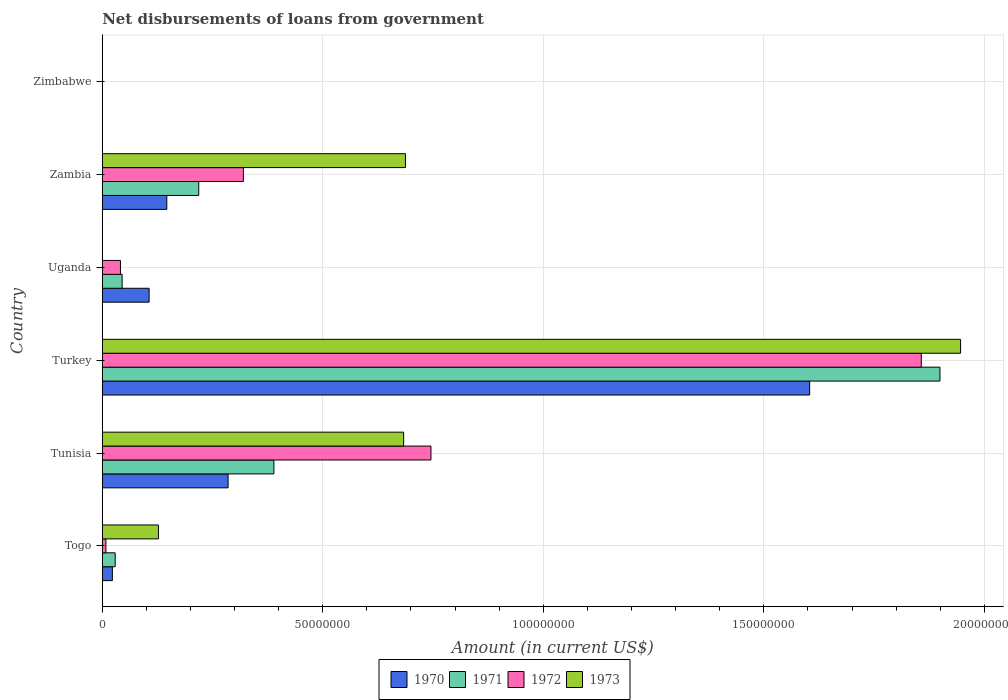How many different coloured bars are there?
Your response must be concise. 4. Are the number of bars on each tick of the Y-axis equal?
Offer a very short reply. No. How many bars are there on the 6th tick from the top?
Offer a terse response. 4. How many bars are there on the 6th tick from the bottom?
Offer a terse response. 0. What is the label of the 6th group of bars from the top?
Provide a succinct answer. Togo. What is the amount of loan disbursed from government in 1973 in Zambia?
Your answer should be very brief. 6.88e+07. Across all countries, what is the maximum amount of loan disbursed from government in 1971?
Your response must be concise. 1.90e+08. In which country was the amount of loan disbursed from government in 1972 maximum?
Provide a succinct answer. Turkey. What is the total amount of loan disbursed from government in 1970 in the graph?
Offer a very short reply. 2.16e+08. What is the difference between the amount of loan disbursed from government in 1973 in Togo and that in Tunisia?
Your response must be concise. -5.56e+07. What is the difference between the amount of loan disbursed from government in 1971 in Tunisia and the amount of loan disbursed from government in 1972 in Turkey?
Provide a succinct answer. -1.47e+08. What is the average amount of loan disbursed from government in 1973 per country?
Make the answer very short. 5.74e+07. What is the difference between the amount of loan disbursed from government in 1973 and amount of loan disbursed from government in 1972 in Turkey?
Make the answer very short. 8.91e+06. What is the ratio of the amount of loan disbursed from government in 1971 in Turkey to that in Zambia?
Offer a terse response. 8.68. Is the amount of loan disbursed from government in 1970 in Turkey less than that in Uganda?
Provide a short and direct response. No. What is the difference between the highest and the second highest amount of loan disbursed from government in 1972?
Ensure brevity in your answer.  1.11e+08. What is the difference between the highest and the lowest amount of loan disbursed from government in 1972?
Give a very brief answer. 1.86e+08. Is the sum of the amount of loan disbursed from government in 1970 in Uganda and Zambia greater than the maximum amount of loan disbursed from government in 1972 across all countries?
Provide a succinct answer. No. Is it the case that in every country, the sum of the amount of loan disbursed from government in 1970 and amount of loan disbursed from government in 1971 is greater than the sum of amount of loan disbursed from government in 1973 and amount of loan disbursed from government in 1972?
Your answer should be compact. No. How many bars are there?
Offer a very short reply. 19. Are all the bars in the graph horizontal?
Your answer should be very brief. Yes. How many countries are there in the graph?
Offer a very short reply. 6. Does the graph contain any zero values?
Provide a succinct answer. Yes. Does the graph contain grids?
Your answer should be very brief. Yes. Where does the legend appear in the graph?
Provide a succinct answer. Bottom center. How are the legend labels stacked?
Provide a short and direct response. Horizontal. What is the title of the graph?
Offer a very short reply. Net disbursements of loans from government. What is the label or title of the X-axis?
Your response must be concise. Amount (in current US$). What is the label or title of the Y-axis?
Give a very brief answer. Country. What is the Amount (in current US$) in 1970 in Togo?
Offer a terse response. 2.30e+06. What is the Amount (in current US$) of 1971 in Togo?
Your answer should be compact. 2.94e+06. What is the Amount (in current US$) in 1972 in Togo?
Give a very brief answer. 8.31e+05. What is the Amount (in current US$) of 1973 in Togo?
Provide a succinct answer. 1.27e+07. What is the Amount (in current US$) in 1970 in Tunisia?
Your response must be concise. 2.85e+07. What is the Amount (in current US$) of 1971 in Tunisia?
Ensure brevity in your answer.  3.89e+07. What is the Amount (in current US$) of 1972 in Tunisia?
Offer a very short reply. 7.45e+07. What is the Amount (in current US$) of 1973 in Tunisia?
Your response must be concise. 6.83e+07. What is the Amount (in current US$) in 1970 in Turkey?
Offer a terse response. 1.60e+08. What is the Amount (in current US$) in 1971 in Turkey?
Your response must be concise. 1.90e+08. What is the Amount (in current US$) of 1972 in Turkey?
Provide a succinct answer. 1.86e+08. What is the Amount (in current US$) in 1973 in Turkey?
Offer a very short reply. 1.95e+08. What is the Amount (in current US$) of 1970 in Uganda?
Ensure brevity in your answer.  1.06e+07. What is the Amount (in current US$) of 1971 in Uganda?
Your answer should be compact. 4.51e+06. What is the Amount (in current US$) in 1972 in Uganda?
Provide a short and direct response. 4.13e+06. What is the Amount (in current US$) of 1970 in Zambia?
Offer a terse response. 1.46e+07. What is the Amount (in current US$) of 1971 in Zambia?
Your answer should be compact. 2.19e+07. What is the Amount (in current US$) in 1972 in Zambia?
Give a very brief answer. 3.20e+07. What is the Amount (in current US$) in 1973 in Zambia?
Give a very brief answer. 6.88e+07. What is the Amount (in current US$) of 1972 in Zimbabwe?
Provide a succinct answer. 0. Across all countries, what is the maximum Amount (in current US$) of 1970?
Provide a short and direct response. 1.60e+08. Across all countries, what is the maximum Amount (in current US$) of 1971?
Offer a very short reply. 1.90e+08. Across all countries, what is the maximum Amount (in current US$) in 1972?
Offer a terse response. 1.86e+08. Across all countries, what is the maximum Amount (in current US$) in 1973?
Keep it short and to the point. 1.95e+08. Across all countries, what is the minimum Amount (in current US$) in 1970?
Your answer should be compact. 0. Across all countries, what is the minimum Amount (in current US$) of 1973?
Your answer should be very brief. 0. What is the total Amount (in current US$) in 1970 in the graph?
Provide a succinct answer. 2.16e+08. What is the total Amount (in current US$) in 1971 in the graph?
Your answer should be compact. 2.58e+08. What is the total Amount (in current US$) in 1972 in the graph?
Keep it short and to the point. 2.97e+08. What is the total Amount (in current US$) of 1973 in the graph?
Provide a short and direct response. 3.44e+08. What is the difference between the Amount (in current US$) in 1970 in Togo and that in Tunisia?
Offer a very short reply. -2.62e+07. What is the difference between the Amount (in current US$) in 1971 in Togo and that in Tunisia?
Make the answer very short. -3.60e+07. What is the difference between the Amount (in current US$) in 1972 in Togo and that in Tunisia?
Offer a terse response. -7.37e+07. What is the difference between the Amount (in current US$) of 1973 in Togo and that in Tunisia?
Provide a succinct answer. -5.56e+07. What is the difference between the Amount (in current US$) of 1970 in Togo and that in Turkey?
Provide a succinct answer. -1.58e+08. What is the difference between the Amount (in current US$) in 1971 in Togo and that in Turkey?
Keep it short and to the point. -1.87e+08. What is the difference between the Amount (in current US$) in 1972 in Togo and that in Turkey?
Offer a terse response. -1.85e+08. What is the difference between the Amount (in current US$) of 1973 in Togo and that in Turkey?
Your answer should be very brief. -1.82e+08. What is the difference between the Amount (in current US$) in 1970 in Togo and that in Uganda?
Your answer should be very brief. -8.33e+06. What is the difference between the Amount (in current US$) in 1971 in Togo and that in Uganda?
Keep it short and to the point. -1.57e+06. What is the difference between the Amount (in current US$) in 1972 in Togo and that in Uganda?
Provide a succinct answer. -3.30e+06. What is the difference between the Amount (in current US$) in 1970 in Togo and that in Zambia?
Offer a terse response. -1.23e+07. What is the difference between the Amount (in current US$) in 1971 in Togo and that in Zambia?
Keep it short and to the point. -1.89e+07. What is the difference between the Amount (in current US$) in 1972 in Togo and that in Zambia?
Offer a terse response. -3.12e+07. What is the difference between the Amount (in current US$) in 1973 in Togo and that in Zambia?
Your answer should be compact. -5.60e+07. What is the difference between the Amount (in current US$) in 1970 in Tunisia and that in Turkey?
Your response must be concise. -1.32e+08. What is the difference between the Amount (in current US$) of 1971 in Tunisia and that in Turkey?
Make the answer very short. -1.51e+08. What is the difference between the Amount (in current US$) of 1972 in Tunisia and that in Turkey?
Your response must be concise. -1.11e+08. What is the difference between the Amount (in current US$) in 1973 in Tunisia and that in Turkey?
Provide a succinct answer. -1.26e+08. What is the difference between the Amount (in current US$) of 1970 in Tunisia and that in Uganda?
Your answer should be very brief. 1.79e+07. What is the difference between the Amount (in current US$) in 1971 in Tunisia and that in Uganda?
Provide a short and direct response. 3.44e+07. What is the difference between the Amount (in current US$) in 1972 in Tunisia and that in Uganda?
Ensure brevity in your answer.  7.04e+07. What is the difference between the Amount (in current US$) in 1970 in Tunisia and that in Zambia?
Offer a very short reply. 1.39e+07. What is the difference between the Amount (in current US$) in 1971 in Tunisia and that in Zambia?
Provide a short and direct response. 1.70e+07. What is the difference between the Amount (in current US$) in 1972 in Tunisia and that in Zambia?
Offer a very short reply. 4.25e+07. What is the difference between the Amount (in current US$) in 1973 in Tunisia and that in Zambia?
Ensure brevity in your answer.  -4.12e+05. What is the difference between the Amount (in current US$) in 1970 in Turkey and that in Uganda?
Your answer should be very brief. 1.50e+08. What is the difference between the Amount (in current US$) of 1971 in Turkey and that in Uganda?
Your answer should be compact. 1.85e+08. What is the difference between the Amount (in current US$) of 1972 in Turkey and that in Uganda?
Keep it short and to the point. 1.82e+08. What is the difference between the Amount (in current US$) in 1970 in Turkey and that in Zambia?
Provide a short and direct response. 1.46e+08. What is the difference between the Amount (in current US$) of 1971 in Turkey and that in Zambia?
Your response must be concise. 1.68e+08. What is the difference between the Amount (in current US$) in 1972 in Turkey and that in Zambia?
Your answer should be compact. 1.54e+08. What is the difference between the Amount (in current US$) in 1973 in Turkey and that in Zambia?
Offer a terse response. 1.26e+08. What is the difference between the Amount (in current US$) of 1970 in Uganda and that in Zambia?
Provide a succinct answer. -4.01e+06. What is the difference between the Amount (in current US$) in 1971 in Uganda and that in Zambia?
Provide a succinct answer. -1.74e+07. What is the difference between the Amount (in current US$) in 1972 in Uganda and that in Zambia?
Your answer should be very brief. -2.79e+07. What is the difference between the Amount (in current US$) in 1970 in Togo and the Amount (in current US$) in 1971 in Tunisia?
Provide a short and direct response. -3.66e+07. What is the difference between the Amount (in current US$) in 1970 in Togo and the Amount (in current US$) in 1972 in Tunisia?
Ensure brevity in your answer.  -7.22e+07. What is the difference between the Amount (in current US$) in 1970 in Togo and the Amount (in current US$) in 1973 in Tunisia?
Ensure brevity in your answer.  -6.60e+07. What is the difference between the Amount (in current US$) in 1971 in Togo and the Amount (in current US$) in 1972 in Tunisia?
Offer a very short reply. -7.16e+07. What is the difference between the Amount (in current US$) of 1971 in Togo and the Amount (in current US$) of 1973 in Tunisia?
Offer a very short reply. -6.54e+07. What is the difference between the Amount (in current US$) of 1972 in Togo and the Amount (in current US$) of 1973 in Tunisia?
Offer a terse response. -6.75e+07. What is the difference between the Amount (in current US$) in 1970 in Togo and the Amount (in current US$) in 1971 in Turkey?
Offer a very short reply. -1.88e+08. What is the difference between the Amount (in current US$) in 1970 in Togo and the Amount (in current US$) in 1972 in Turkey?
Offer a very short reply. -1.83e+08. What is the difference between the Amount (in current US$) in 1970 in Togo and the Amount (in current US$) in 1973 in Turkey?
Provide a succinct answer. -1.92e+08. What is the difference between the Amount (in current US$) in 1971 in Togo and the Amount (in current US$) in 1972 in Turkey?
Give a very brief answer. -1.83e+08. What is the difference between the Amount (in current US$) in 1971 in Togo and the Amount (in current US$) in 1973 in Turkey?
Make the answer very short. -1.92e+08. What is the difference between the Amount (in current US$) in 1972 in Togo and the Amount (in current US$) in 1973 in Turkey?
Provide a succinct answer. -1.94e+08. What is the difference between the Amount (in current US$) in 1970 in Togo and the Amount (in current US$) in 1971 in Uganda?
Offer a terse response. -2.21e+06. What is the difference between the Amount (in current US$) of 1970 in Togo and the Amount (in current US$) of 1972 in Uganda?
Offer a terse response. -1.83e+06. What is the difference between the Amount (in current US$) in 1971 in Togo and the Amount (in current US$) in 1972 in Uganda?
Ensure brevity in your answer.  -1.20e+06. What is the difference between the Amount (in current US$) in 1970 in Togo and the Amount (in current US$) in 1971 in Zambia?
Offer a terse response. -1.96e+07. What is the difference between the Amount (in current US$) in 1970 in Togo and the Amount (in current US$) in 1972 in Zambia?
Provide a short and direct response. -2.97e+07. What is the difference between the Amount (in current US$) in 1970 in Togo and the Amount (in current US$) in 1973 in Zambia?
Give a very brief answer. -6.65e+07. What is the difference between the Amount (in current US$) in 1971 in Togo and the Amount (in current US$) in 1972 in Zambia?
Give a very brief answer. -2.91e+07. What is the difference between the Amount (in current US$) in 1971 in Togo and the Amount (in current US$) in 1973 in Zambia?
Your answer should be very brief. -6.58e+07. What is the difference between the Amount (in current US$) of 1972 in Togo and the Amount (in current US$) of 1973 in Zambia?
Offer a very short reply. -6.79e+07. What is the difference between the Amount (in current US$) of 1970 in Tunisia and the Amount (in current US$) of 1971 in Turkey?
Offer a terse response. -1.61e+08. What is the difference between the Amount (in current US$) in 1970 in Tunisia and the Amount (in current US$) in 1972 in Turkey?
Provide a succinct answer. -1.57e+08. What is the difference between the Amount (in current US$) in 1970 in Tunisia and the Amount (in current US$) in 1973 in Turkey?
Make the answer very short. -1.66e+08. What is the difference between the Amount (in current US$) of 1971 in Tunisia and the Amount (in current US$) of 1972 in Turkey?
Your response must be concise. -1.47e+08. What is the difference between the Amount (in current US$) in 1971 in Tunisia and the Amount (in current US$) in 1973 in Turkey?
Offer a very short reply. -1.56e+08. What is the difference between the Amount (in current US$) of 1972 in Tunisia and the Amount (in current US$) of 1973 in Turkey?
Offer a terse response. -1.20e+08. What is the difference between the Amount (in current US$) in 1970 in Tunisia and the Amount (in current US$) in 1971 in Uganda?
Make the answer very short. 2.40e+07. What is the difference between the Amount (in current US$) of 1970 in Tunisia and the Amount (in current US$) of 1972 in Uganda?
Make the answer very short. 2.44e+07. What is the difference between the Amount (in current US$) of 1971 in Tunisia and the Amount (in current US$) of 1972 in Uganda?
Provide a short and direct response. 3.48e+07. What is the difference between the Amount (in current US$) of 1970 in Tunisia and the Amount (in current US$) of 1971 in Zambia?
Offer a terse response. 6.66e+06. What is the difference between the Amount (in current US$) of 1970 in Tunisia and the Amount (in current US$) of 1972 in Zambia?
Provide a short and direct response. -3.46e+06. What is the difference between the Amount (in current US$) of 1970 in Tunisia and the Amount (in current US$) of 1973 in Zambia?
Ensure brevity in your answer.  -4.02e+07. What is the difference between the Amount (in current US$) of 1971 in Tunisia and the Amount (in current US$) of 1972 in Zambia?
Give a very brief answer. 6.92e+06. What is the difference between the Amount (in current US$) of 1971 in Tunisia and the Amount (in current US$) of 1973 in Zambia?
Your response must be concise. -2.98e+07. What is the difference between the Amount (in current US$) in 1972 in Tunisia and the Amount (in current US$) in 1973 in Zambia?
Your response must be concise. 5.78e+06. What is the difference between the Amount (in current US$) in 1970 in Turkey and the Amount (in current US$) in 1971 in Uganda?
Ensure brevity in your answer.  1.56e+08. What is the difference between the Amount (in current US$) of 1970 in Turkey and the Amount (in current US$) of 1972 in Uganda?
Offer a terse response. 1.56e+08. What is the difference between the Amount (in current US$) of 1971 in Turkey and the Amount (in current US$) of 1972 in Uganda?
Provide a succinct answer. 1.86e+08. What is the difference between the Amount (in current US$) in 1970 in Turkey and the Amount (in current US$) in 1971 in Zambia?
Make the answer very short. 1.39e+08. What is the difference between the Amount (in current US$) of 1970 in Turkey and the Amount (in current US$) of 1972 in Zambia?
Offer a very short reply. 1.28e+08. What is the difference between the Amount (in current US$) in 1970 in Turkey and the Amount (in current US$) in 1973 in Zambia?
Offer a terse response. 9.16e+07. What is the difference between the Amount (in current US$) in 1971 in Turkey and the Amount (in current US$) in 1972 in Zambia?
Offer a terse response. 1.58e+08. What is the difference between the Amount (in current US$) in 1971 in Turkey and the Amount (in current US$) in 1973 in Zambia?
Your answer should be compact. 1.21e+08. What is the difference between the Amount (in current US$) in 1972 in Turkey and the Amount (in current US$) in 1973 in Zambia?
Your answer should be compact. 1.17e+08. What is the difference between the Amount (in current US$) in 1970 in Uganda and the Amount (in current US$) in 1971 in Zambia?
Provide a succinct answer. -1.13e+07. What is the difference between the Amount (in current US$) in 1970 in Uganda and the Amount (in current US$) in 1972 in Zambia?
Your response must be concise. -2.14e+07. What is the difference between the Amount (in current US$) of 1970 in Uganda and the Amount (in current US$) of 1973 in Zambia?
Your answer should be very brief. -5.81e+07. What is the difference between the Amount (in current US$) of 1971 in Uganda and the Amount (in current US$) of 1972 in Zambia?
Your answer should be compact. -2.75e+07. What is the difference between the Amount (in current US$) of 1971 in Uganda and the Amount (in current US$) of 1973 in Zambia?
Provide a succinct answer. -6.42e+07. What is the difference between the Amount (in current US$) in 1972 in Uganda and the Amount (in current US$) in 1973 in Zambia?
Keep it short and to the point. -6.46e+07. What is the average Amount (in current US$) of 1970 per country?
Offer a terse response. 3.61e+07. What is the average Amount (in current US$) in 1971 per country?
Offer a terse response. 4.30e+07. What is the average Amount (in current US$) in 1972 per country?
Your response must be concise. 4.95e+07. What is the average Amount (in current US$) in 1973 per country?
Offer a terse response. 5.74e+07. What is the difference between the Amount (in current US$) of 1970 and Amount (in current US$) of 1971 in Togo?
Provide a short and direct response. -6.37e+05. What is the difference between the Amount (in current US$) of 1970 and Amount (in current US$) of 1972 in Togo?
Make the answer very short. 1.47e+06. What is the difference between the Amount (in current US$) of 1970 and Amount (in current US$) of 1973 in Togo?
Keep it short and to the point. -1.04e+07. What is the difference between the Amount (in current US$) in 1971 and Amount (in current US$) in 1972 in Togo?
Your answer should be very brief. 2.10e+06. What is the difference between the Amount (in current US$) in 1971 and Amount (in current US$) in 1973 in Togo?
Keep it short and to the point. -9.80e+06. What is the difference between the Amount (in current US$) of 1972 and Amount (in current US$) of 1973 in Togo?
Keep it short and to the point. -1.19e+07. What is the difference between the Amount (in current US$) in 1970 and Amount (in current US$) in 1971 in Tunisia?
Provide a short and direct response. -1.04e+07. What is the difference between the Amount (in current US$) of 1970 and Amount (in current US$) of 1972 in Tunisia?
Ensure brevity in your answer.  -4.60e+07. What is the difference between the Amount (in current US$) of 1970 and Amount (in current US$) of 1973 in Tunisia?
Provide a short and direct response. -3.98e+07. What is the difference between the Amount (in current US$) in 1971 and Amount (in current US$) in 1972 in Tunisia?
Provide a short and direct response. -3.56e+07. What is the difference between the Amount (in current US$) of 1971 and Amount (in current US$) of 1973 in Tunisia?
Give a very brief answer. -2.94e+07. What is the difference between the Amount (in current US$) of 1972 and Amount (in current US$) of 1973 in Tunisia?
Provide a short and direct response. 6.20e+06. What is the difference between the Amount (in current US$) of 1970 and Amount (in current US$) of 1971 in Turkey?
Give a very brief answer. -2.95e+07. What is the difference between the Amount (in current US$) in 1970 and Amount (in current US$) in 1972 in Turkey?
Provide a succinct answer. -2.53e+07. What is the difference between the Amount (in current US$) of 1970 and Amount (in current US$) of 1973 in Turkey?
Your answer should be compact. -3.42e+07. What is the difference between the Amount (in current US$) in 1971 and Amount (in current US$) in 1972 in Turkey?
Your response must be concise. 4.24e+06. What is the difference between the Amount (in current US$) in 1971 and Amount (in current US$) in 1973 in Turkey?
Make the answer very short. -4.67e+06. What is the difference between the Amount (in current US$) in 1972 and Amount (in current US$) in 1973 in Turkey?
Provide a succinct answer. -8.91e+06. What is the difference between the Amount (in current US$) of 1970 and Amount (in current US$) of 1971 in Uganda?
Keep it short and to the point. 6.12e+06. What is the difference between the Amount (in current US$) of 1970 and Amount (in current US$) of 1972 in Uganda?
Your answer should be compact. 6.50e+06. What is the difference between the Amount (in current US$) of 1971 and Amount (in current US$) of 1972 in Uganda?
Your answer should be very brief. 3.77e+05. What is the difference between the Amount (in current US$) in 1970 and Amount (in current US$) in 1971 in Zambia?
Your response must be concise. -7.25e+06. What is the difference between the Amount (in current US$) in 1970 and Amount (in current US$) in 1972 in Zambia?
Your answer should be very brief. -1.74e+07. What is the difference between the Amount (in current US$) of 1970 and Amount (in current US$) of 1973 in Zambia?
Your response must be concise. -5.41e+07. What is the difference between the Amount (in current US$) of 1971 and Amount (in current US$) of 1972 in Zambia?
Give a very brief answer. -1.01e+07. What is the difference between the Amount (in current US$) of 1971 and Amount (in current US$) of 1973 in Zambia?
Provide a succinct answer. -4.69e+07. What is the difference between the Amount (in current US$) in 1972 and Amount (in current US$) in 1973 in Zambia?
Provide a succinct answer. -3.68e+07. What is the ratio of the Amount (in current US$) of 1970 in Togo to that in Tunisia?
Offer a very short reply. 0.08. What is the ratio of the Amount (in current US$) in 1971 in Togo to that in Tunisia?
Make the answer very short. 0.08. What is the ratio of the Amount (in current US$) in 1972 in Togo to that in Tunisia?
Your answer should be compact. 0.01. What is the ratio of the Amount (in current US$) in 1973 in Togo to that in Tunisia?
Provide a short and direct response. 0.19. What is the ratio of the Amount (in current US$) in 1970 in Togo to that in Turkey?
Offer a terse response. 0.01. What is the ratio of the Amount (in current US$) of 1971 in Togo to that in Turkey?
Your response must be concise. 0.02. What is the ratio of the Amount (in current US$) of 1972 in Togo to that in Turkey?
Keep it short and to the point. 0. What is the ratio of the Amount (in current US$) of 1973 in Togo to that in Turkey?
Provide a succinct answer. 0.07. What is the ratio of the Amount (in current US$) in 1970 in Togo to that in Uganda?
Offer a terse response. 0.22. What is the ratio of the Amount (in current US$) of 1971 in Togo to that in Uganda?
Give a very brief answer. 0.65. What is the ratio of the Amount (in current US$) of 1972 in Togo to that in Uganda?
Make the answer very short. 0.2. What is the ratio of the Amount (in current US$) in 1970 in Togo to that in Zambia?
Offer a terse response. 0.16. What is the ratio of the Amount (in current US$) of 1971 in Togo to that in Zambia?
Your answer should be very brief. 0.13. What is the ratio of the Amount (in current US$) in 1972 in Togo to that in Zambia?
Provide a short and direct response. 0.03. What is the ratio of the Amount (in current US$) in 1973 in Togo to that in Zambia?
Your answer should be compact. 0.19. What is the ratio of the Amount (in current US$) of 1970 in Tunisia to that in Turkey?
Keep it short and to the point. 0.18. What is the ratio of the Amount (in current US$) in 1971 in Tunisia to that in Turkey?
Provide a short and direct response. 0.2. What is the ratio of the Amount (in current US$) of 1972 in Tunisia to that in Turkey?
Give a very brief answer. 0.4. What is the ratio of the Amount (in current US$) of 1973 in Tunisia to that in Turkey?
Offer a very short reply. 0.35. What is the ratio of the Amount (in current US$) in 1970 in Tunisia to that in Uganda?
Your response must be concise. 2.68. What is the ratio of the Amount (in current US$) of 1971 in Tunisia to that in Uganda?
Your answer should be very brief. 8.64. What is the ratio of the Amount (in current US$) in 1972 in Tunisia to that in Uganda?
Provide a succinct answer. 18.05. What is the ratio of the Amount (in current US$) in 1970 in Tunisia to that in Zambia?
Keep it short and to the point. 1.95. What is the ratio of the Amount (in current US$) in 1971 in Tunisia to that in Zambia?
Give a very brief answer. 1.78. What is the ratio of the Amount (in current US$) of 1972 in Tunisia to that in Zambia?
Give a very brief answer. 2.33. What is the ratio of the Amount (in current US$) in 1970 in Turkey to that in Uganda?
Make the answer very short. 15.09. What is the ratio of the Amount (in current US$) of 1971 in Turkey to that in Uganda?
Your response must be concise. 42.14. What is the ratio of the Amount (in current US$) of 1972 in Turkey to that in Uganda?
Your answer should be very brief. 44.97. What is the ratio of the Amount (in current US$) in 1970 in Turkey to that in Zambia?
Keep it short and to the point. 10.96. What is the ratio of the Amount (in current US$) in 1971 in Turkey to that in Zambia?
Your answer should be very brief. 8.68. What is the ratio of the Amount (in current US$) of 1972 in Turkey to that in Zambia?
Provide a succinct answer. 5.8. What is the ratio of the Amount (in current US$) in 1973 in Turkey to that in Zambia?
Your response must be concise. 2.83. What is the ratio of the Amount (in current US$) in 1970 in Uganda to that in Zambia?
Offer a very short reply. 0.73. What is the ratio of the Amount (in current US$) in 1971 in Uganda to that in Zambia?
Ensure brevity in your answer.  0.21. What is the ratio of the Amount (in current US$) of 1972 in Uganda to that in Zambia?
Provide a short and direct response. 0.13. What is the difference between the highest and the second highest Amount (in current US$) of 1970?
Your response must be concise. 1.32e+08. What is the difference between the highest and the second highest Amount (in current US$) of 1971?
Give a very brief answer. 1.51e+08. What is the difference between the highest and the second highest Amount (in current US$) of 1972?
Your answer should be very brief. 1.11e+08. What is the difference between the highest and the second highest Amount (in current US$) in 1973?
Your answer should be compact. 1.26e+08. What is the difference between the highest and the lowest Amount (in current US$) in 1970?
Give a very brief answer. 1.60e+08. What is the difference between the highest and the lowest Amount (in current US$) in 1971?
Keep it short and to the point. 1.90e+08. What is the difference between the highest and the lowest Amount (in current US$) of 1972?
Your response must be concise. 1.86e+08. What is the difference between the highest and the lowest Amount (in current US$) in 1973?
Keep it short and to the point. 1.95e+08. 